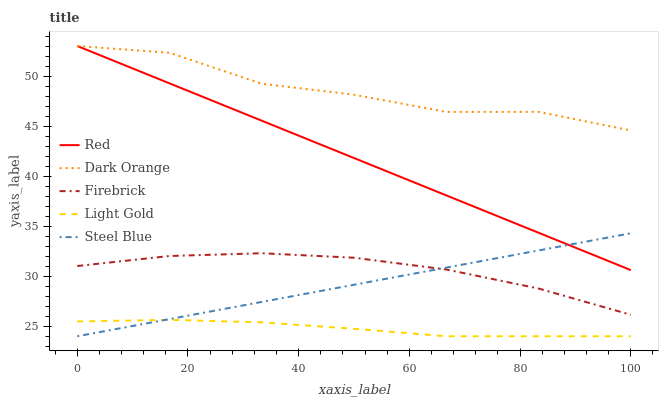Does Light Gold have the minimum area under the curve?
Answer yes or no. Yes. Does Dark Orange have the maximum area under the curve?
Answer yes or no. Yes. Does Firebrick have the minimum area under the curve?
Answer yes or no. No. Does Firebrick have the maximum area under the curve?
Answer yes or no. No. Is Steel Blue the smoothest?
Answer yes or no. Yes. Is Dark Orange the roughest?
Answer yes or no. Yes. Is Firebrick the smoothest?
Answer yes or no. No. Is Firebrick the roughest?
Answer yes or no. No. Does Light Gold have the lowest value?
Answer yes or no. Yes. Does Firebrick have the lowest value?
Answer yes or no. No. Does Red have the highest value?
Answer yes or no. Yes. Does Firebrick have the highest value?
Answer yes or no. No. Is Light Gold less than Dark Orange?
Answer yes or no. Yes. Is Dark Orange greater than Steel Blue?
Answer yes or no. Yes. Does Steel Blue intersect Firebrick?
Answer yes or no. Yes. Is Steel Blue less than Firebrick?
Answer yes or no. No. Is Steel Blue greater than Firebrick?
Answer yes or no. No. Does Light Gold intersect Dark Orange?
Answer yes or no. No. 